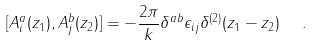Convert formula to latex. <formula><loc_0><loc_0><loc_500><loc_500>[ A _ { i } ^ { a } ( z _ { 1 } ) , A _ { j } ^ { b } ( z _ { 2 } ) ] = - \frac { 2 \pi } { k } \delta ^ { a b } \epsilon _ { i j } \delta ^ { ( 2 ) } ( z _ { 1 } - z _ { 2 } ) \ \ .</formula> 